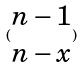Convert formula to latex. <formula><loc_0><loc_0><loc_500><loc_500>( \begin{matrix} n - 1 \\ n - x \end{matrix} )</formula> 